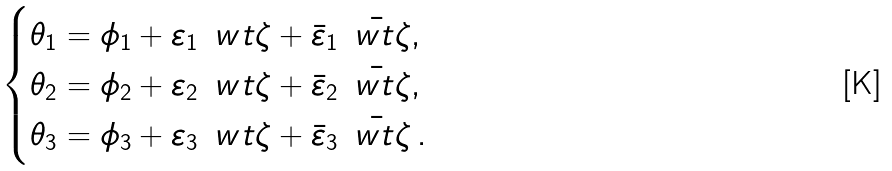<formula> <loc_0><loc_0><loc_500><loc_500>\begin{cases} \theta _ { 1 } = \phi _ { 1 } + \varepsilon _ { 1 } \, { \ w t \zeta } + \bar { \varepsilon } _ { 1 } \, \bar { \ w t \zeta } , \\ \theta _ { 2 } = \phi _ { 2 } + \varepsilon _ { 2 } \, { \ w t \zeta } + \bar { \varepsilon } _ { 2 } \, \bar { \ w t \zeta } , \\ \theta _ { 3 } = \phi _ { 3 } + \varepsilon _ { 3 } \, { \ w t \zeta } + \bar { \varepsilon } _ { 3 } \, \bar { \ w t \zeta } \, . \end{cases}</formula> 